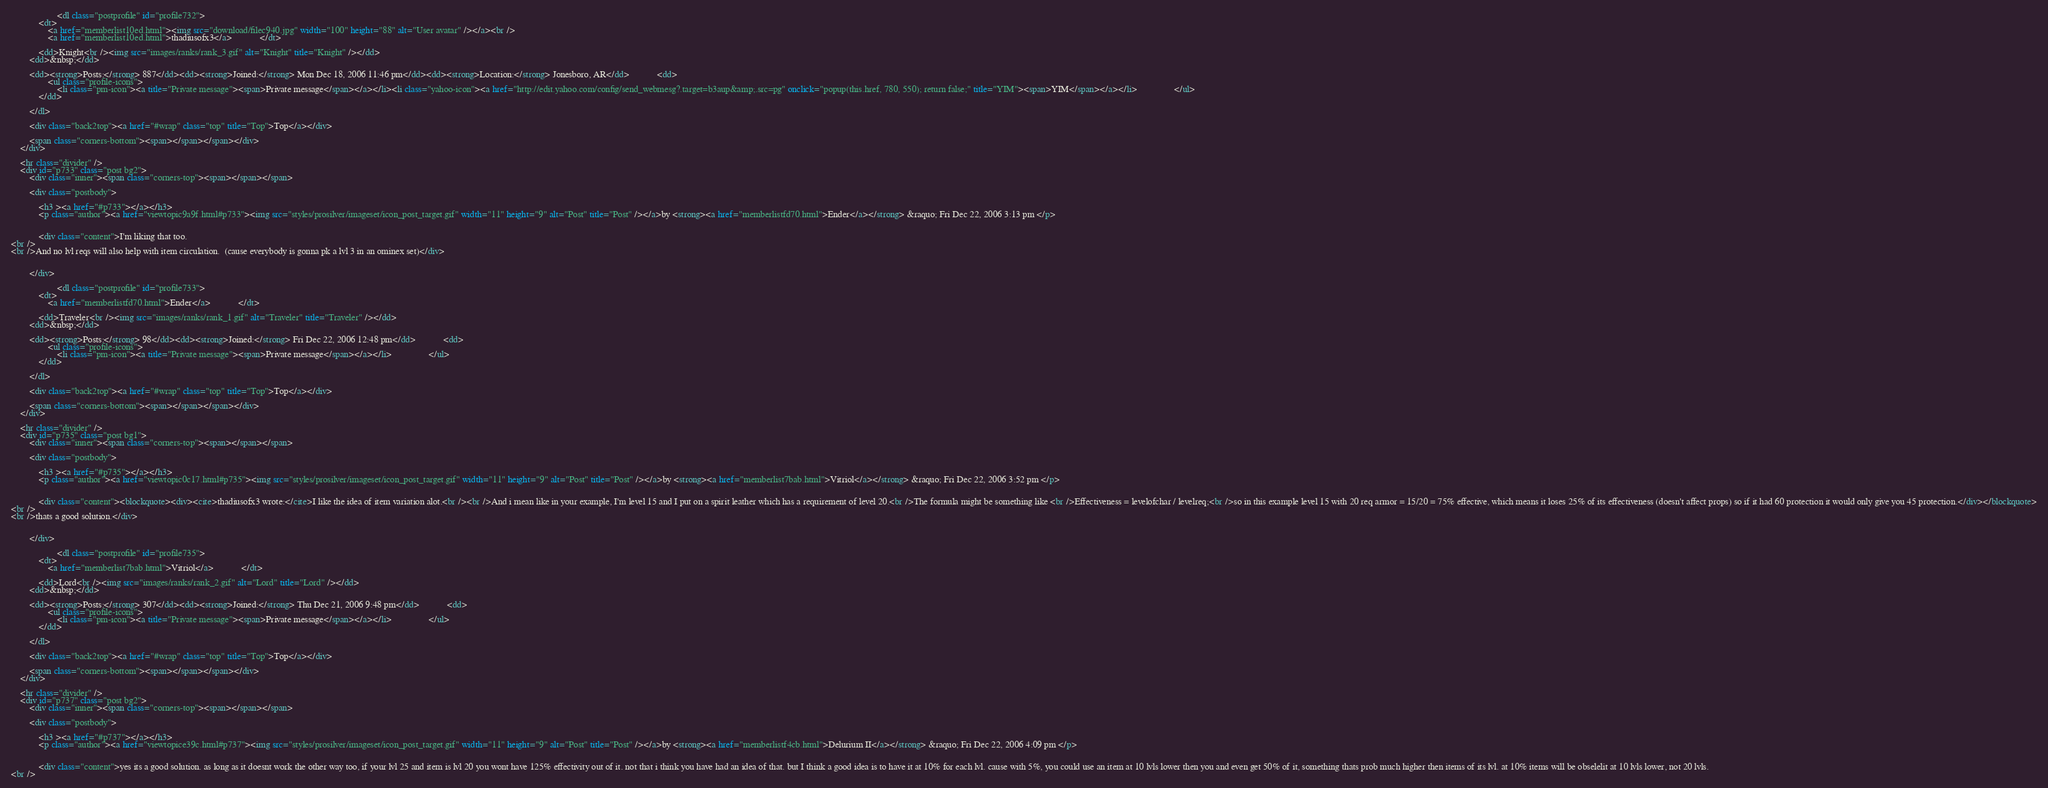Convert code to text. <code><loc_0><loc_0><loc_500><loc_500><_HTML_>
					<dl class="postprofile" id="profile732">
			<dt>
				<a href="memberlist10ed.html"><img src="download/filec940.jpg" width="100" height="88" alt="User avatar" /></a><br />
				<a href="memberlist10ed.html">thadiusofx3</a>			</dt>

			<dd>Knight<br /><img src="images/ranks/rank_3.gif" alt="Knight" title="Knight" /></dd>
		<dd>&nbsp;</dd>

		<dd><strong>Posts:</strong> 887</dd><dd><strong>Joined:</strong> Mon Dec 18, 2006 11:46 pm</dd><dd><strong>Location:</strong> Jonesboro, AR</dd>			<dd>
				<ul class="profile-icons">
					<li class="pm-icon"><a title="Private message"><span>Private message</span></a></li><li class="yahoo-icon"><a href="http://edit.yahoo.com/config/send_webmesg?.target=b3aup&amp;.src=pg" onclick="popup(this.href, 780, 550); return false;" title="YIM"><span>YIM</span></a></li>				</ul>
			</dd>
		
		</dl>
	
		<div class="back2top"><a href="#wrap" class="top" title="Top">Top</a></div>

		<span class="corners-bottom"><span></span></span></div>
	</div>

	<hr class="divider" />
	<div id="p733" class="post bg2">
		<div class="inner"><span class="corners-top"><span></span></span>

		<div class="postbody">
			
			<h3 ><a href="#p733"></a></h3>
			<p class="author"><a href="viewtopic9a9f.html#p733"><img src="styles/prosilver/imageset/icon_post_target.gif" width="11" height="9" alt="Post" title="Post" /></a>by <strong><a href="memberlistfd70.html">Ender</a></strong> &raquo; Fri Dec 22, 2006 3:13 pm </p>

			
			<div class="content">I'm liking that too. 
<br />
<br />And no lvl reqs will also help with item circulation.  (cause everybody is gonna pk a lvl 3 in an ominex set)</div>

			
		</div>

					<dl class="postprofile" id="profile733">
			<dt>
				<a href="memberlistfd70.html">Ender</a>			</dt>

			<dd>Traveler<br /><img src="images/ranks/rank_1.gif" alt="Traveler" title="Traveler" /></dd>
		<dd>&nbsp;</dd>

		<dd><strong>Posts:</strong> 98</dd><dd><strong>Joined:</strong> Fri Dec 22, 2006 12:48 pm</dd>			<dd>
				<ul class="profile-icons">
					<li class="pm-icon"><a title="Private message"><span>Private message</span></a></li>				</ul>
			</dd>
		
		</dl>
	
		<div class="back2top"><a href="#wrap" class="top" title="Top">Top</a></div>

		<span class="corners-bottom"><span></span></span></div>
	</div>

	<hr class="divider" />
	<div id="p735" class="post bg1">
		<div class="inner"><span class="corners-top"><span></span></span>

		<div class="postbody">
			
			<h3 ><a href="#p735"></a></h3>
			<p class="author"><a href="viewtopic0c17.html#p735"><img src="styles/prosilver/imageset/icon_post_target.gif" width="11" height="9" alt="Post" title="Post" /></a>by <strong><a href="memberlist7bab.html">Vitriol</a></strong> &raquo; Fri Dec 22, 2006 3:52 pm </p>

			
			<div class="content"><blockquote><div><cite>thadiusofx3 wrote:</cite>I like the idea of item variation alot.<br /><br />And i mean like in your example, I'm level 15 and I put on a spirit leather which has a requirement of level 20.<br />The formula might be something like <br />Effectiveness = levelofchar / levelreq;<br />so in this example level 15 with 20 req armor = 15/20 = 75% effective, which means it loses 25% of its effectiveness (doesn't affect props) so if it had 60 protection it would only give you 45 protection.</div></blockquote>
<br />
<br />thats a good solution.</div>

			
		</div>

					<dl class="postprofile" id="profile735">
			<dt>
				<a href="memberlist7bab.html">Vitriol</a>			</dt>

			<dd>Lord<br /><img src="images/ranks/rank_2.gif" alt="Lord" title="Lord" /></dd>
		<dd>&nbsp;</dd>

		<dd><strong>Posts:</strong> 307</dd><dd><strong>Joined:</strong> Thu Dec 21, 2006 9:48 pm</dd>			<dd>
				<ul class="profile-icons">
					<li class="pm-icon"><a title="Private message"><span>Private message</span></a></li>				</ul>
			</dd>
		
		</dl>
	
		<div class="back2top"><a href="#wrap" class="top" title="Top">Top</a></div>

		<span class="corners-bottom"><span></span></span></div>
	</div>

	<hr class="divider" />
	<div id="p737" class="post bg2">
		<div class="inner"><span class="corners-top"><span></span></span>

		<div class="postbody">
			
			<h3 ><a href="#p737"></a></h3>
			<p class="author"><a href="viewtopice39c.html#p737"><img src="styles/prosilver/imageset/icon_post_target.gif" width="11" height="9" alt="Post" title="Post" /></a>by <strong><a href="memberlistf4cb.html">Delurium II</a></strong> &raquo; Fri Dec 22, 2006 4:09 pm </p>

			
			<div class="content">yes its a good solution. as long as it doesnt work the other way too, if your lvl 25 and item is lvl 20 you wont have 125% effectivity out of it. not that i think you have had an idea of that. but I think a good idea is to have it at 10% for each lvl. cause with 5%, you could use an item at 10 lvls lower then you and even get 50% of it, something thats prob much higher then items of its lvl. at 10% items will be obselelit at 10 lvls lower, not 20 lvls.
<br /></code> 